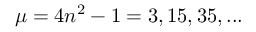Convert formula to latex. <formula><loc_0><loc_0><loc_500><loc_500>\mu = 4 n ^ { 2 } - 1 = 3 , 1 5 , 3 5 , \dots</formula> 